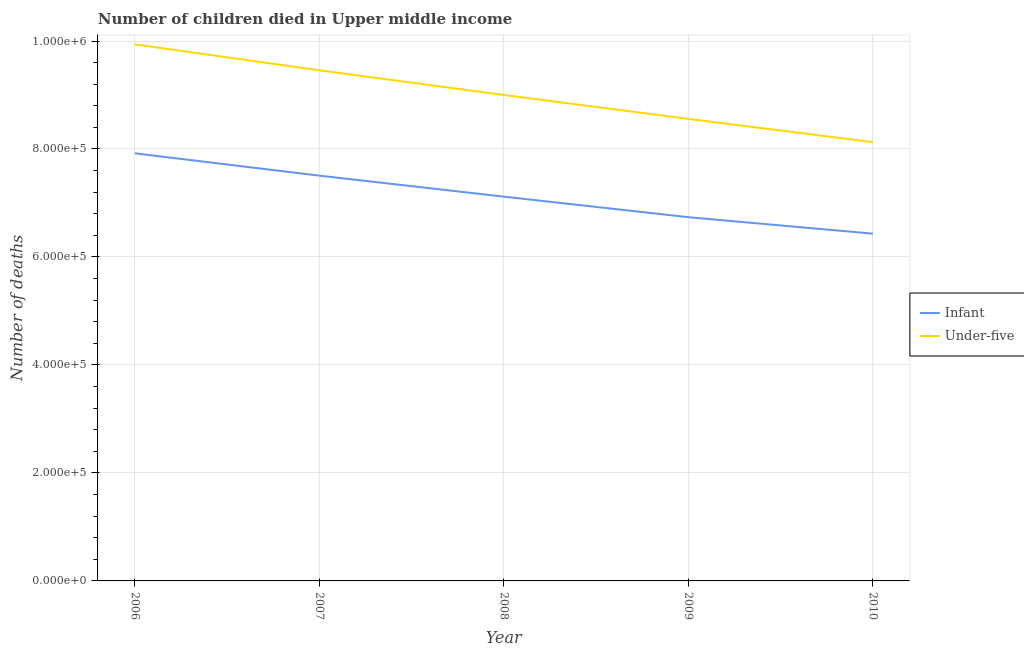How many different coloured lines are there?
Your response must be concise. 2. Does the line corresponding to number of under-five deaths intersect with the line corresponding to number of infant deaths?
Your answer should be compact. No. Is the number of lines equal to the number of legend labels?
Provide a short and direct response. Yes. What is the number of infant deaths in 2006?
Give a very brief answer. 7.92e+05. Across all years, what is the maximum number of infant deaths?
Ensure brevity in your answer.  7.92e+05. Across all years, what is the minimum number of infant deaths?
Keep it short and to the point. 6.43e+05. In which year was the number of infant deaths maximum?
Your answer should be very brief. 2006. What is the total number of infant deaths in the graph?
Offer a terse response. 3.57e+06. What is the difference between the number of under-five deaths in 2006 and that in 2008?
Your answer should be compact. 9.38e+04. What is the difference between the number of under-five deaths in 2010 and the number of infant deaths in 2008?
Ensure brevity in your answer.  1.01e+05. What is the average number of under-five deaths per year?
Keep it short and to the point. 9.02e+05. In the year 2009, what is the difference between the number of infant deaths and number of under-five deaths?
Provide a succinct answer. -1.82e+05. What is the ratio of the number of under-five deaths in 2006 to that in 2007?
Give a very brief answer. 1.05. Is the number of under-five deaths in 2008 less than that in 2009?
Your answer should be compact. No. What is the difference between the highest and the second highest number of under-five deaths?
Offer a terse response. 4.80e+04. What is the difference between the highest and the lowest number of infant deaths?
Offer a terse response. 1.49e+05. Does the number of under-five deaths monotonically increase over the years?
Give a very brief answer. No. Is the number of under-five deaths strictly less than the number of infant deaths over the years?
Offer a very short reply. No. How many lines are there?
Provide a succinct answer. 2. How many years are there in the graph?
Your answer should be very brief. 5. Are the values on the major ticks of Y-axis written in scientific E-notation?
Offer a very short reply. Yes. Does the graph contain grids?
Keep it short and to the point. Yes. Where does the legend appear in the graph?
Offer a terse response. Center right. How many legend labels are there?
Give a very brief answer. 2. What is the title of the graph?
Ensure brevity in your answer.  Number of children died in Upper middle income. What is the label or title of the X-axis?
Offer a terse response. Year. What is the label or title of the Y-axis?
Offer a very short reply. Number of deaths. What is the Number of deaths of Infant in 2006?
Your response must be concise. 7.92e+05. What is the Number of deaths in Under-five in 2006?
Make the answer very short. 9.94e+05. What is the Number of deaths in Infant in 2007?
Offer a terse response. 7.51e+05. What is the Number of deaths of Under-five in 2007?
Your response must be concise. 9.46e+05. What is the Number of deaths of Infant in 2008?
Provide a short and direct response. 7.12e+05. What is the Number of deaths of Under-five in 2008?
Your answer should be compact. 9.00e+05. What is the Number of deaths of Infant in 2009?
Offer a very short reply. 6.74e+05. What is the Number of deaths of Under-five in 2009?
Give a very brief answer. 8.56e+05. What is the Number of deaths in Infant in 2010?
Give a very brief answer. 6.43e+05. What is the Number of deaths of Under-five in 2010?
Provide a short and direct response. 8.13e+05. Across all years, what is the maximum Number of deaths of Infant?
Offer a very short reply. 7.92e+05. Across all years, what is the maximum Number of deaths in Under-five?
Your answer should be compact. 9.94e+05. Across all years, what is the minimum Number of deaths of Infant?
Offer a terse response. 6.43e+05. Across all years, what is the minimum Number of deaths of Under-five?
Your answer should be very brief. 8.13e+05. What is the total Number of deaths of Infant in the graph?
Keep it short and to the point. 3.57e+06. What is the total Number of deaths of Under-five in the graph?
Ensure brevity in your answer.  4.51e+06. What is the difference between the Number of deaths of Infant in 2006 and that in 2007?
Offer a very short reply. 4.14e+04. What is the difference between the Number of deaths in Under-five in 2006 and that in 2007?
Offer a terse response. 4.80e+04. What is the difference between the Number of deaths of Infant in 2006 and that in 2008?
Ensure brevity in your answer.  8.03e+04. What is the difference between the Number of deaths of Under-five in 2006 and that in 2008?
Give a very brief answer. 9.38e+04. What is the difference between the Number of deaths in Infant in 2006 and that in 2009?
Give a very brief answer. 1.18e+05. What is the difference between the Number of deaths in Under-five in 2006 and that in 2009?
Offer a terse response. 1.38e+05. What is the difference between the Number of deaths in Infant in 2006 and that in 2010?
Give a very brief answer. 1.49e+05. What is the difference between the Number of deaths of Under-five in 2006 and that in 2010?
Offer a terse response. 1.81e+05. What is the difference between the Number of deaths in Infant in 2007 and that in 2008?
Ensure brevity in your answer.  3.89e+04. What is the difference between the Number of deaths of Under-five in 2007 and that in 2008?
Make the answer very short. 4.57e+04. What is the difference between the Number of deaths of Infant in 2007 and that in 2009?
Offer a terse response. 7.70e+04. What is the difference between the Number of deaths of Under-five in 2007 and that in 2009?
Offer a very short reply. 9.00e+04. What is the difference between the Number of deaths in Infant in 2007 and that in 2010?
Keep it short and to the point. 1.07e+05. What is the difference between the Number of deaths in Under-five in 2007 and that in 2010?
Your answer should be very brief. 1.33e+05. What is the difference between the Number of deaths of Infant in 2008 and that in 2009?
Offer a very short reply. 3.81e+04. What is the difference between the Number of deaths of Under-five in 2008 and that in 2009?
Make the answer very short. 4.43e+04. What is the difference between the Number of deaths in Infant in 2008 and that in 2010?
Your answer should be compact. 6.86e+04. What is the difference between the Number of deaths of Under-five in 2008 and that in 2010?
Offer a very short reply. 8.73e+04. What is the difference between the Number of deaths of Infant in 2009 and that in 2010?
Your response must be concise. 3.05e+04. What is the difference between the Number of deaths in Under-five in 2009 and that in 2010?
Provide a short and direct response. 4.30e+04. What is the difference between the Number of deaths in Infant in 2006 and the Number of deaths in Under-five in 2007?
Keep it short and to the point. -1.54e+05. What is the difference between the Number of deaths of Infant in 2006 and the Number of deaths of Under-five in 2008?
Offer a terse response. -1.08e+05. What is the difference between the Number of deaths in Infant in 2006 and the Number of deaths in Under-five in 2009?
Ensure brevity in your answer.  -6.38e+04. What is the difference between the Number of deaths in Infant in 2006 and the Number of deaths in Under-five in 2010?
Offer a very short reply. -2.07e+04. What is the difference between the Number of deaths in Infant in 2007 and the Number of deaths in Under-five in 2008?
Offer a very short reply. -1.49e+05. What is the difference between the Number of deaths in Infant in 2007 and the Number of deaths in Under-five in 2009?
Your response must be concise. -1.05e+05. What is the difference between the Number of deaths of Infant in 2007 and the Number of deaths of Under-five in 2010?
Ensure brevity in your answer.  -6.21e+04. What is the difference between the Number of deaths of Infant in 2008 and the Number of deaths of Under-five in 2009?
Ensure brevity in your answer.  -1.44e+05. What is the difference between the Number of deaths of Infant in 2008 and the Number of deaths of Under-five in 2010?
Offer a terse response. -1.01e+05. What is the difference between the Number of deaths of Infant in 2009 and the Number of deaths of Under-five in 2010?
Offer a very short reply. -1.39e+05. What is the average Number of deaths of Infant per year?
Keep it short and to the point. 7.14e+05. What is the average Number of deaths of Under-five per year?
Your answer should be very brief. 9.02e+05. In the year 2006, what is the difference between the Number of deaths in Infant and Number of deaths in Under-five?
Your answer should be very brief. -2.02e+05. In the year 2007, what is the difference between the Number of deaths in Infant and Number of deaths in Under-five?
Offer a terse response. -1.95e+05. In the year 2008, what is the difference between the Number of deaths of Infant and Number of deaths of Under-five?
Offer a very short reply. -1.88e+05. In the year 2009, what is the difference between the Number of deaths of Infant and Number of deaths of Under-five?
Your response must be concise. -1.82e+05. In the year 2010, what is the difference between the Number of deaths of Infant and Number of deaths of Under-five?
Offer a terse response. -1.70e+05. What is the ratio of the Number of deaths in Infant in 2006 to that in 2007?
Keep it short and to the point. 1.06. What is the ratio of the Number of deaths in Under-five in 2006 to that in 2007?
Make the answer very short. 1.05. What is the ratio of the Number of deaths of Infant in 2006 to that in 2008?
Your answer should be compact. 1.11. What is the ratio of the Number of deaths in Under-five in 2006 to that in 2008?
Your answer should be compact. 1.1. What is the ratio of the Number of deaths in Infant in 2006 to that in 2009?
Your answer should be compact. 1.18. What is the ratio of the Number of deaths of Under-five in 2006 to that in 2009?
Your answer should be very brief. 1.16. What is the ratio of the Number of deaths of Infant in 2006 to that in 2010?
Make the answer very short. 1.23. What is the ratio of the Number of deaths in Under-five in 2006 to that in 2010?
Offer a terse response. 1.22. What is the ratio of the Number of deaths of Infant in 2007 to that in 2008?
Your response must be concise. 1.05. What is the ratio of the Number of deaths of Under-five in 2007 to that in 2008?
Make the answer very short. 1.05. What is the ratio of the Number of deaths of Infant in 2007 to that in 2009?
Your answer should be compact. 1.11. What is the ratio of the Number of deaths in Under-five in 2007 to that in 2009?
Your answer should be compact. 1.11. What is the ratio of the Number of deaths in Infant in 2007 to that in 2010?
Give a very brief answer. 1.17. What is the ratio of the Number of deaths in Under-five in 2007 to that in 2010?
Provide a succinct answer. 1.16. What is the ratio of the Number of deaths of Infant in 2008 to that in 2009?
Provide a succinct answer. 1.06. What is the ratio of the Number of deaths of Under-five in 2008 to that in 2009?
Provide a short and direct response. 1.05. What is the ratio of the Number of deaths of Infant in 2008 to that in 2010?
Your answer should be very brief. 1.11. What is the ratio of the Number of deaths in Under-five in 2008 to that in 2010?
Give a very brief answer. 1.11. What is the ratio of the Number of deaths of Infant in 2009 to that in 2010?
Provide a succinct answer. 1.05. What is the ratio of the Number of deaths of Under-five in 2009 to that in 2010?
Your answer should be compact. 1.05. What is the difference between the highest and the second highest Number of deaths in Infant?
Provide a succinct answer. 4.14e+04. What is the difference between the highest and the second highest Number of deaths of Under-five?
Make the answer very short. 4.80e+04. What is the difference between the highest and the lowest Number of deaths of Infant?
Provide a succinct answer. 1.49e+05. What is the difference between the highest and the lowest Number of deaths in Under-five?
Provide a succinct answer. 1.81e+05. 